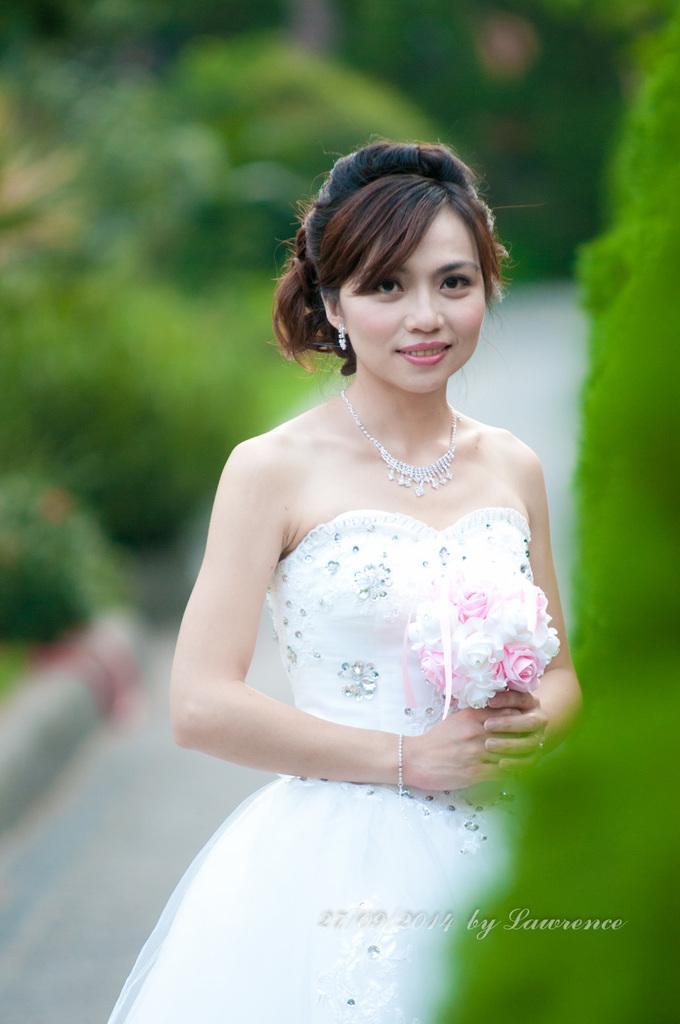In one or two sentences, can you explain what this image depicts? In this image we can see a woman is standing, she is holding bouquet in her hand and wearing white color dress. 